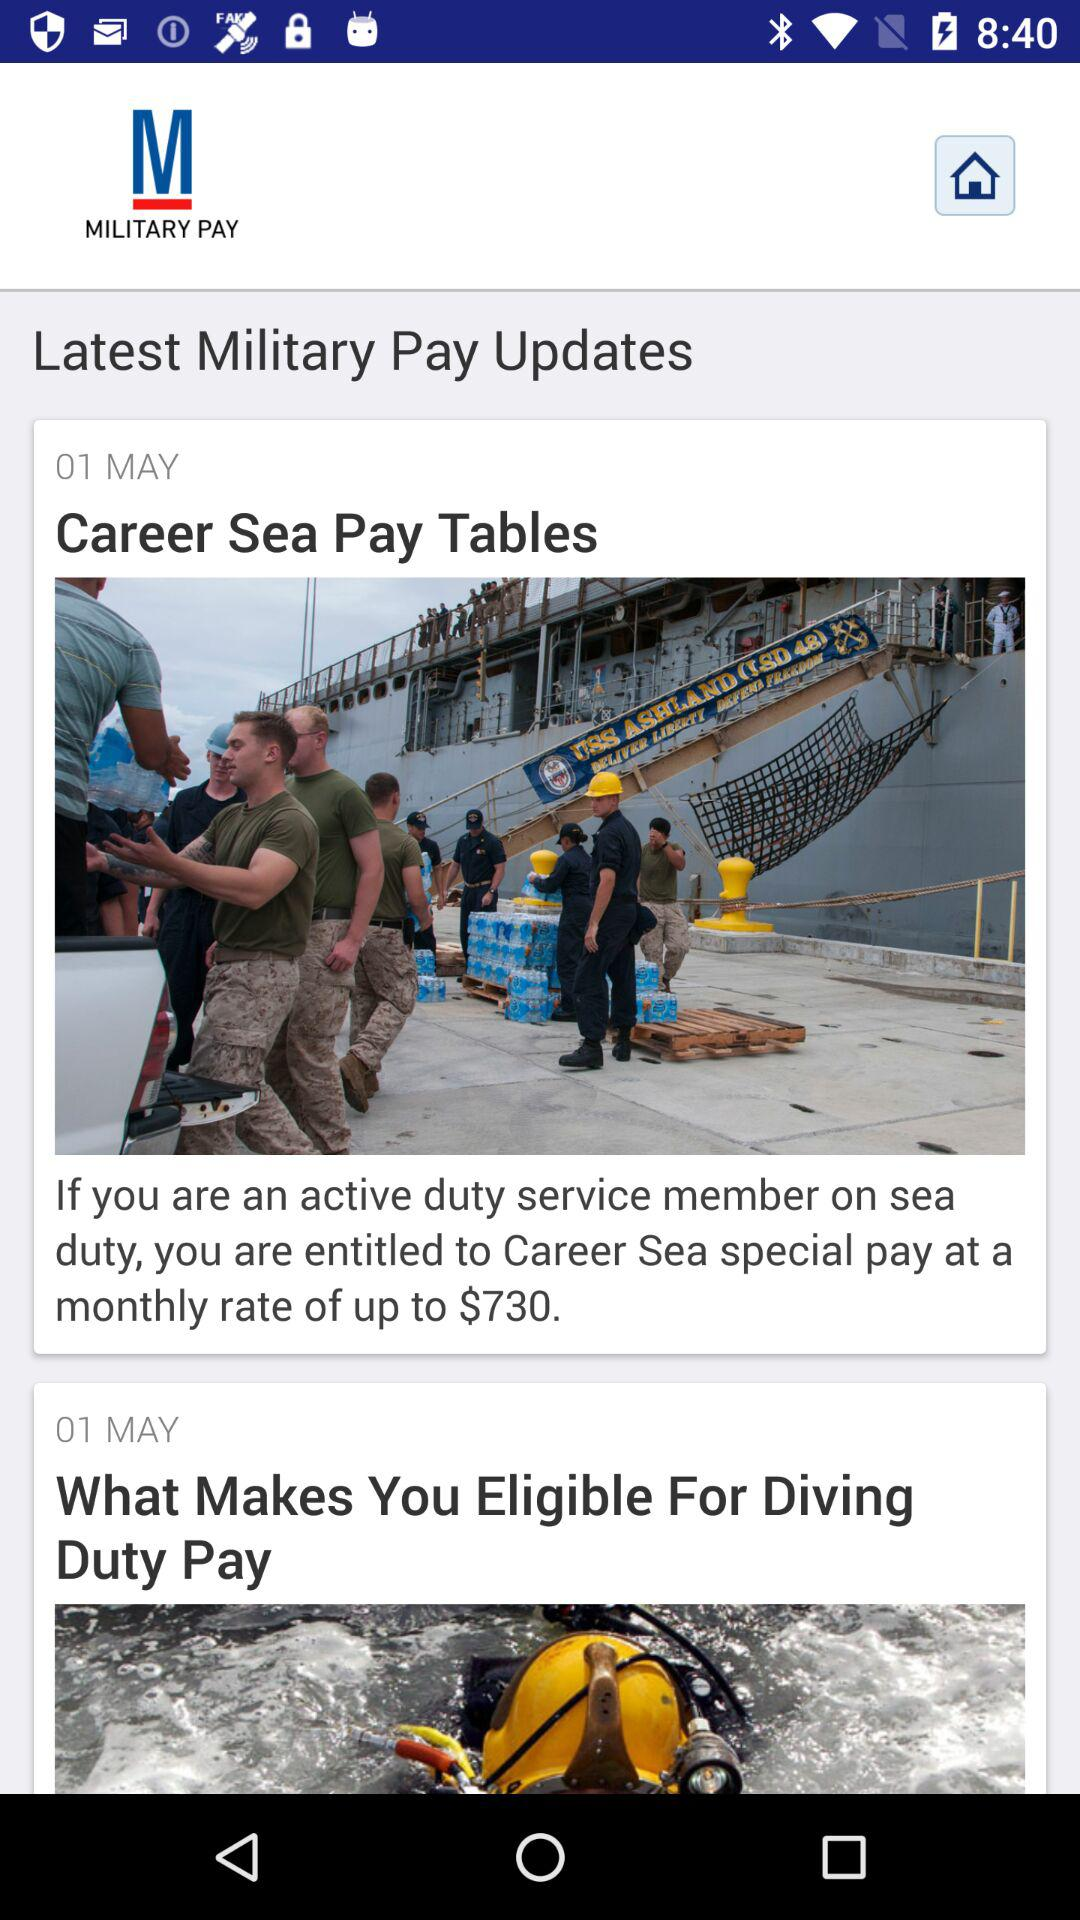What is the name of the application? The name of the application is "MILITARY PAY". 